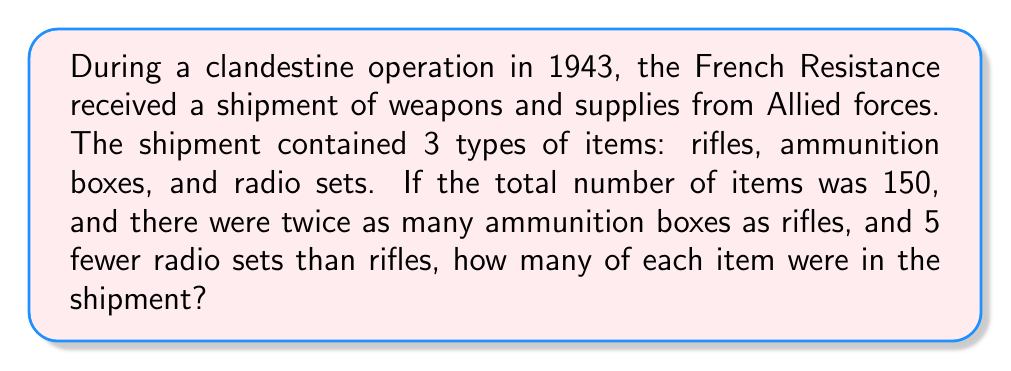Teach me how to tackle this problem. Let's approach this step-by-step:

1) Let $x$ be the number of rifles.
2) Then, the number of ammunition boxes is $2x$.
3) The number of radio sets is $x - 5$.

4) We know that the total number of items is 150, so we can set up the equation:
   
   $x + 2x + (x - 5) = 150$

5) Simplify the left side of the equation:
   
   $4x - 5 = 150$

6) Add 5 to both sides:
   
   $4x = 155$

7) Divide both sides by 4:
   
   $x = 38.75$

8) Since we can't have a fractional number of items, we round down to 38 rifles.

9) Now we can calculate the other items:
   - Ammunition boxes: $2 * 38 = 76$
   - Radio sets: $38 - 5 = 33$

10) Let's verify: $38 + 76 + 33 = 147$, which is close to 150, accounting for our rounding.

Therefore, the shipment contained 38 rifles, 76 ammunition boxes, and 33 radio sets.
Answer: 38 rifles, 76 ammunition boxes, 33 radio sets 